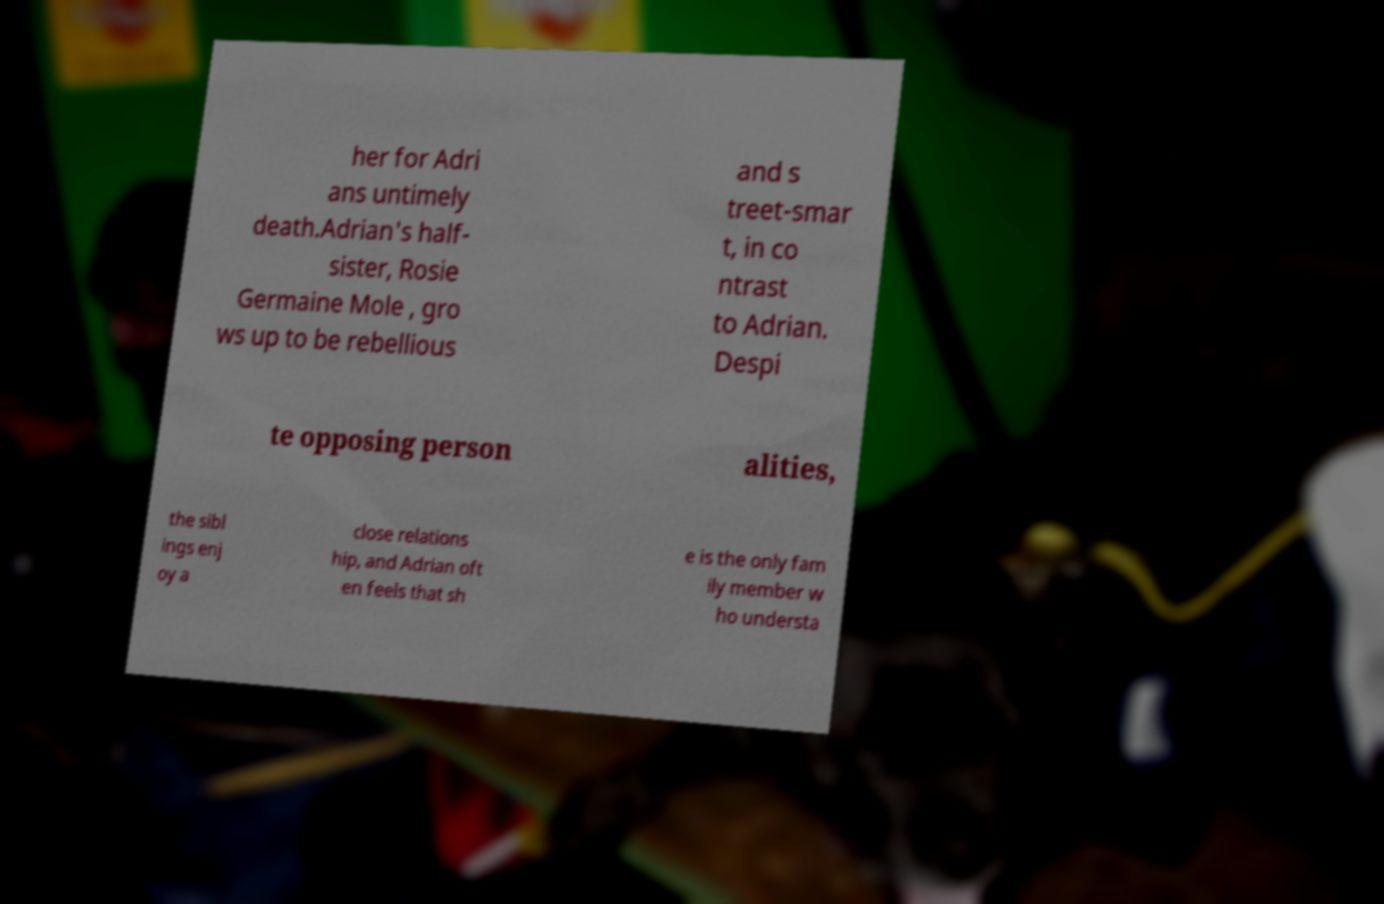Can you read and provide the text displayed in the image?This photo seems to have some interesting text. Can you extract and type it out for me? her for Adri ans untimely death.Adrian's half- sister, Rosie Germaine Mole , gro ws up to be rebellious and s treet-smar t, in co ntrast to Adrian. Despi te opposing person alities, the sibl ings enj oy a close relations hip, and Adrian oft en feels that sh e is the only fam ily member w ho understa 